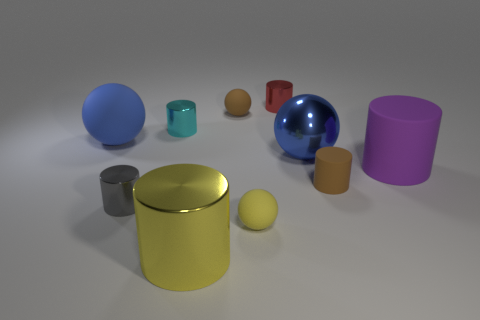How many blue balls must be subtracted to get 1 blue balls? 1 Subtract all brown balls. How many balls are left? 3 Subtract all brown spheres. How many spheres are left? 3 Subtract 1 spheres. How many spheres are left? 3 Subtract all red balls. How many yellow cylinders are left? 1 Subtract all small green matte spheres. Subtract all metal objects. How many objects are left? 5 Add 7 purple rubber things. How many purple rubber things are left? 8 Add 8 big blue balls. How many big blue balls exist? 10 Subtract 0 red spheres. How many objects are left? 10 Subtract all cylinders. How many objects are left? 4 